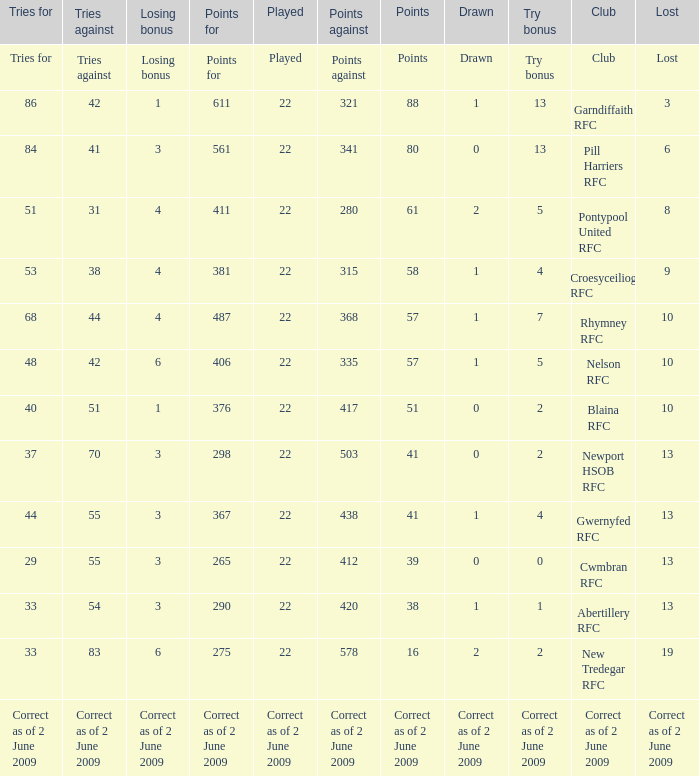How many tries did the club Croesyceiliog rfc have? 53.0. Can you parse all the data within this table? {'header': ['Tries for', 'Tries against', 'Losing bonus', 'Points for', 'Played', 'Points against', 'Points', 'Drawn', 'Try bonus', 'Club', 'Lost'], 'rows': [['Tries for', 'Tries against', 'Losing bonus', 'Points for', 'Played', 'Points against', 'Points', 'Drawn', 'Try bonus', 'Club', 'Lost'], ['86', '42', '1', '611', '22', '321', '88', '1', '13', 'Garndiffaith RFC', '3'], ['84', '41', '3', '561', '22', '341', '80', '0', '13', 'Pill Harriers RFC', '6'], ['51', '31', '4', '411', '22', '280', '61', '2', '5', 'Pontypool United RFC', '8'], ['53', '38', '4', '381', '22', '315', '58', '1', '4', 'Croesyceiliog RFC', '9'], ['68', '44', '4', '487', '22', '368', '57', '1', '7', 'Rhymney RFC', '10'], ['48', '42', '6', '406', '22', '335', '57', '1', '5', 'Nelson RFC', '10'], ['40', '51', '1', '376', '22', '417', '51', '0', '2', 'Blaina RFC', '10'], ['37', '70', '3', '298', '22', '503', '41', '0', '2', 'Newport HSOB RFC', '13'], ['44', '55', '3', '367', '22', '438', '41', '1', '4', 'Gwernyfed RFC', '13'], ['29', '55', '3', '265', '22', '412', '39', '0', '0', 'Cwmbran RFC', '13'], ['33', '54', '3', '290', '22', '420', '38', '1', '1', 'Abertillery RFC', '13'], ['33', '83', '6', '275', '22', '578', '16', '2', '2', 'New Tredegar RFC', '19'], ['Correct as of 2 June 2009', 'Correct as of 2 June 2009', 'Correct as of 2 June 2009', 'Correct as of 2 June 2009', 'Correct as of 2 June 2009', 'Correct as of 2 June 2009', 'Correct as of 2 June 2009', 'Correct as of 2 June 2009', 'Correct as of 2 June 2009', 'Correct as of 2 June 2009', 'Correct as of 2 June 2009']]} 